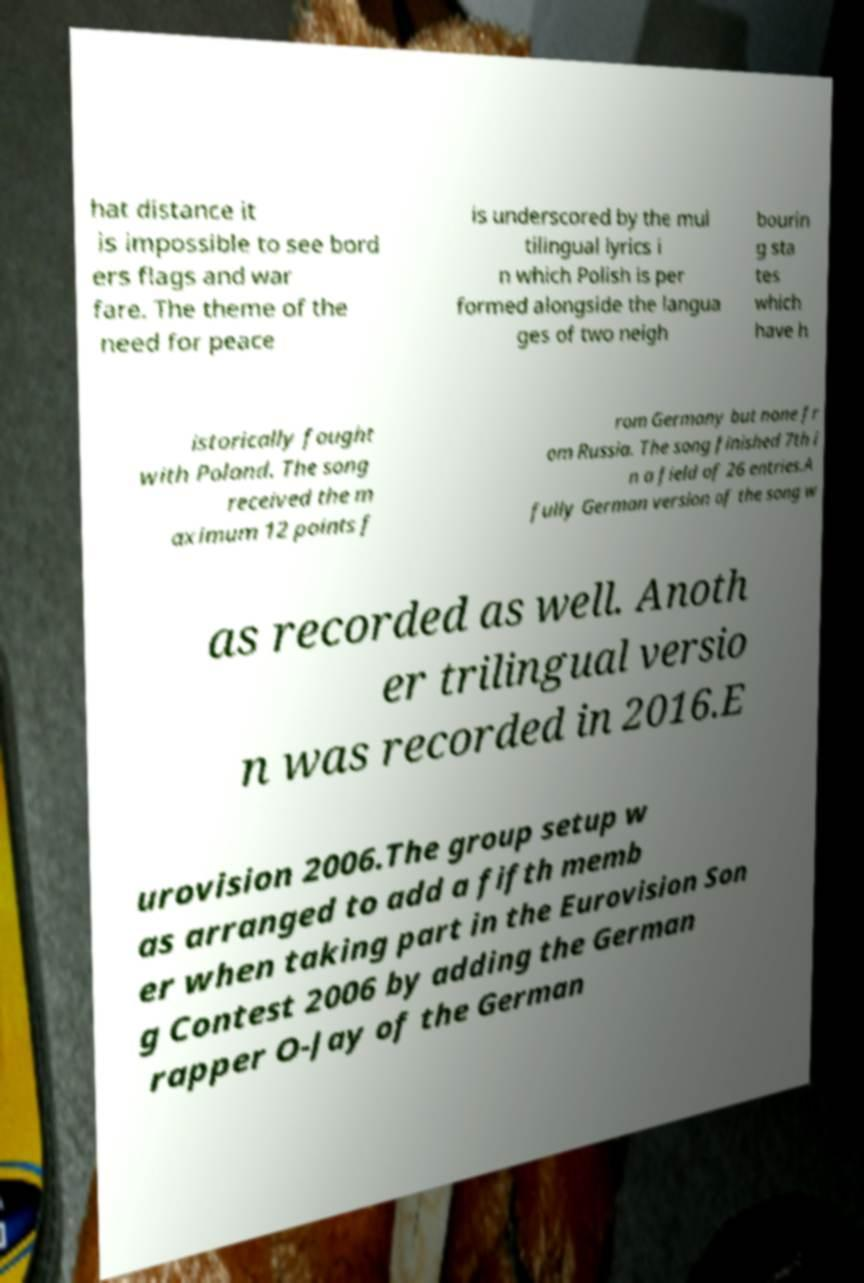Please identify and transcribe the text found in this image. hat distance it is impossible to see bord ers flags and war fare. The theme of the need for peace is underscored by the mul tilingual lyrics i n which Polish is per formed alongside the langua ges of two neigh bourin g sta tes which have h istorically fought with Poland. The song received the m aximum 12 points f rom Germany but none fr om Russia. The song finished 7th i n a field of 26 entries.A fully German version of the song w as recorded as well. Anoth er trilingual versio n was recorded in 2016.E urovision 2006.The group setup w as arranged to add a fifth memb er when taking part in the Eurovision Son g Contest 2006 by adding the German rapper O-Jay of the German 